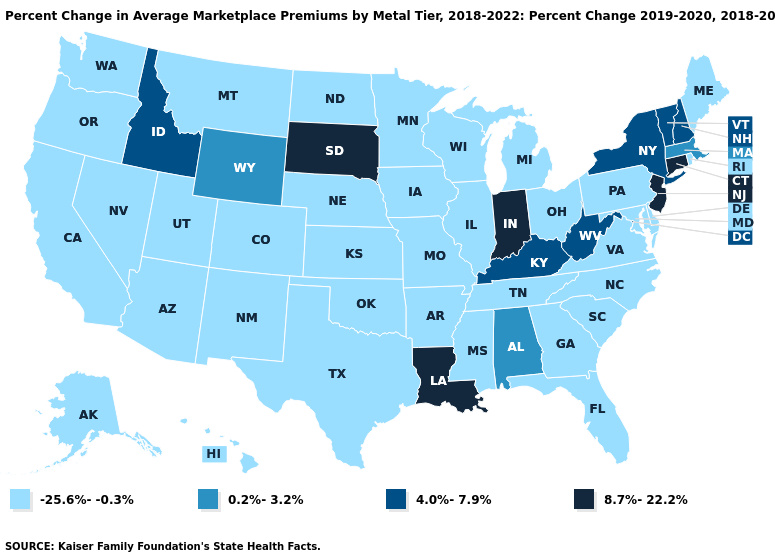What is the value of Alaska?
Keep it brief. -25.6%--0.3%. Name the states that have a value in the range 8.7%-22.2%?
Short answer required. Connecticut, Indiana, Louisiana, New Jersey, South Dakota. Name the states that have a value in the range 0.2%-3.2%?
Short answer required. Alabama, Massachusetts, Wyoming. What is the value of Delaware?
Short answer required. -25.6%--0.3%. What is the value of Pennsylvania?
Write a very short answer. -25.6%--0.3%. What is the value of Massachusetts?
Answer briefly. 0.2%-3.2%. Name the states that have a value in the range 4.0%-7.9%?
Be succinct. Idaho, Kentucky, New Hampshire, New York, Vermont, West Virginia. What is the highest value in the South ?
Keep it brief. 8.7%-22.2%. What is the value of Oklahoma?
Short answer required. -25.6%--0.3%. Is the legend a continuous bar?
Be succinct. No. What is the value of Arkansas?
Keep it brief. -25.6%--0.3%. Name the states that have a value in the range 0.2%-3.2%?
Write a very short answer. Alabama, Massachusetts, Wyoming. What is the value of Virginia?
Write a very short answer. -25.6%--0.3%. What is the value of Nevada?
Be succinct. -25.6%--0.3%. Name the states that have a value in the range 8.7%-22.2%?
Write a very short answer. Connecticut, Indiana, Louisiana, New Jersey, South Dakota. 